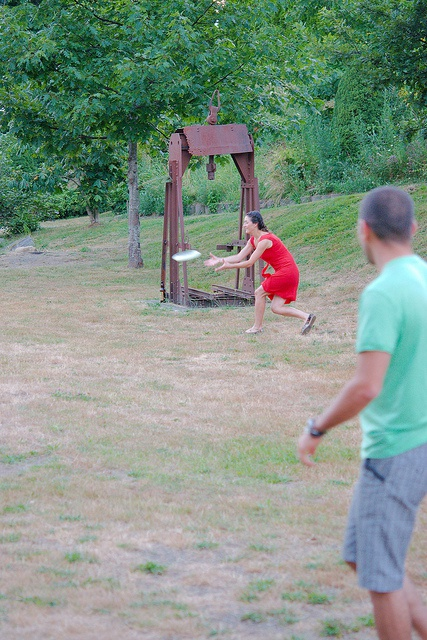Describe the objects in this image and their specific colors. I can see people in darkblue, darkgray, lightblue, and brown tones, people in darkblue, darkgray, lightpink, and brown tones, and frisbee in darkblue, white, lightblue, and darkgray tones in this image. 